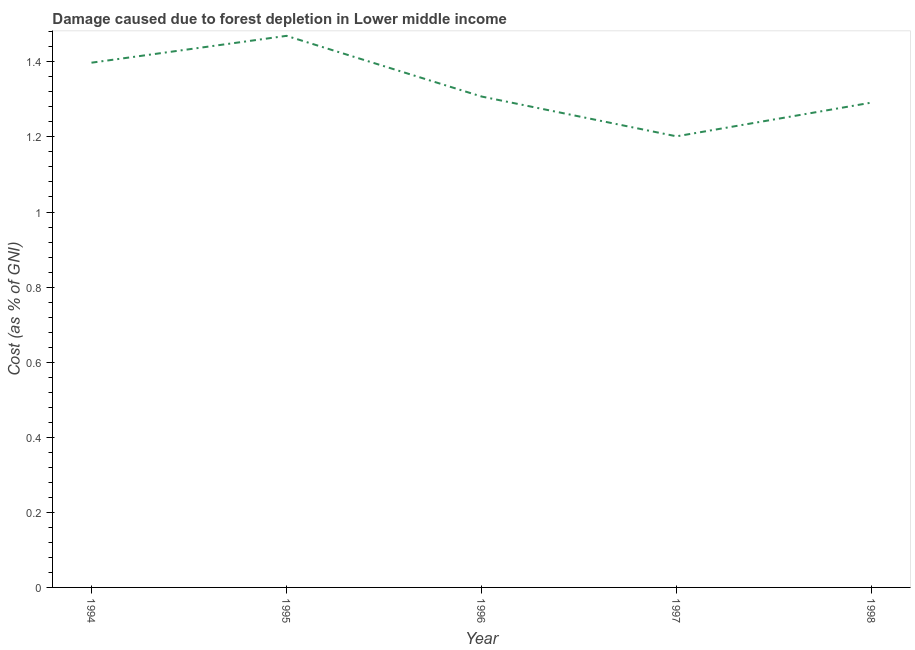What is the damage caused due to forest depletion in 1995?
Give a very brief answer. 1.47. Across all years, what is the maximum damage caused due to forest depletion?
Provide a short and direct response. 1.47. Across all years, what is the minimum damage caused due to forest depletion?
Your answer should be very brief. 1.2. In which year was the damage caused due to forest depletion maximum?
Ensure brevity in your answer.  1995. In which year was the damage caused due to forest depletion minimum?
Your response must be concise. 1997. What is the sum of the damage caused due to forest depletion?
Give a very brief answer. 6.67. What is the difference between the damage caused due to forest depletion in 1995 and 1997?
Ensure brevity in your answer.  0.27. What is the average damage caused due to forest depletion per year?
Provide a succinct answer. 1.33. What is the median damage caused due to forest depletion?
Give a very brief answer. 1.31. Do a majority of the years between 1995 and 1996 (inclusive) have damage caused due to forest depletion greater than 0.2 %?
Provide a short and direct response. Yes. What is the ratio of the damage caused due to forest depletion in 1997 to that in 1998?
Your answer should be compact. 0.93. What is the difference between the highest and the second highest damage caused due to forest depletion?
Offer a very short reply. 0.07. What is the difference between the highest and the lowest damage caused due to forest depletion?
Provide a short and direct response. 0.27. How many lines are there?
Give a very brief answer. 1. How many years are there in the graph?
Ensure brevity in your answer.  5. Are the values on the major ticks of Y-axis written in scientific E-notation?
Offer a terse response. No. What is the title of the graph?
Your response must be concise. Damage caused due to forest depletion in Lower middle income. What is the label or title of the Y-axis?
Make the answer very short. Cost (as % of GNI). What is the Cost (as % of GNI) of 1994?
Offer a very short reply. 1.4. What is the Cost (as % of GNI) of 1995?
Give a very brief answer. 1.47. What is the Cost (as % of GNI) in 1996?
Offer a terse response. 1.31. What is the Cost (as % of GNI) in 1997?
Make the answer very short. 1.2. What is the Cost (as % of GNI) in 1998?
Provide a short and direct response. 1.29. What is the difference between the Cost (as % of GNI) in 1994 and 1995?
Make the answer very short. -0.07. What is the difference between the Cost (as % of GNI) in 1994 and 1996?
Your answer should be very brief. 0.09. What is the difference between the Cost (as % of GNI) in 1994 and 1997?
Your response must be concise. 0.2. What is the difference between the Cost (as % of GNI) in 1994 and 1998?
Your response must be concise. 0.11. What is the difference between the Cost (as % of GNI) in 1995 and 1996?
Your answer should be compact. 0.16. What is the difference between the Cost (as % of GNI) in 1995 and 1997?
Give a very brief answer. 0.27. What is the difference between the Cost (as % of GNI) in 1995 and 1998?
Your answer should be compact. 0.18. What is the difference between the Cost (as % of GNI) in 1996 and 1997?
Give a very brief answer. 0.11. What is the difference between the Cost (as % of GNI) in 1996 and 1998?
Provide a succinct answer. 0.02. What is the difference between the Cost (as % of GNI) in 1997 and 1998?
Your answer should be compact. -0.09. What is the ratio of the Cost (as % of GNI) in 1994 to that in 1995?
Ensure brevity in your answer.  0.95. What is the ratio of the Cost (as % of GNI) in 1994 to that in 1996?
Your answer should be very brief. 1.07. What is the ratio of the Cost (as % of GNI) in 1994 to that in 1997?
Ensure brevity in your answer.  1.16. What is the ratio of the Cost (as % of GNI) in 1994 to that in 1998?
Keep it short and to the point. 1.08. What is the ratio of the Cost (as % of GNI) in 1995 to that in 1996?
Ensure brevity in your answer.  1.12. What is the ratio of the Cost (as % of GNI) in 1995 to that in 1997?
Make the answer very short. 1.22. What is the ratio of the Cost (as % of GNI) in 1995 to that in 1998?
Your answer should be very brief. 1.14. What is the ratio of the Cost (as % of GNI) in 1996 to that in 1997?
Offer a very short reply. 1.09. What is the ratio of the Cost (as % of GNI) in 1997 to that in 1998?
Make the answer very short. 0.93. 